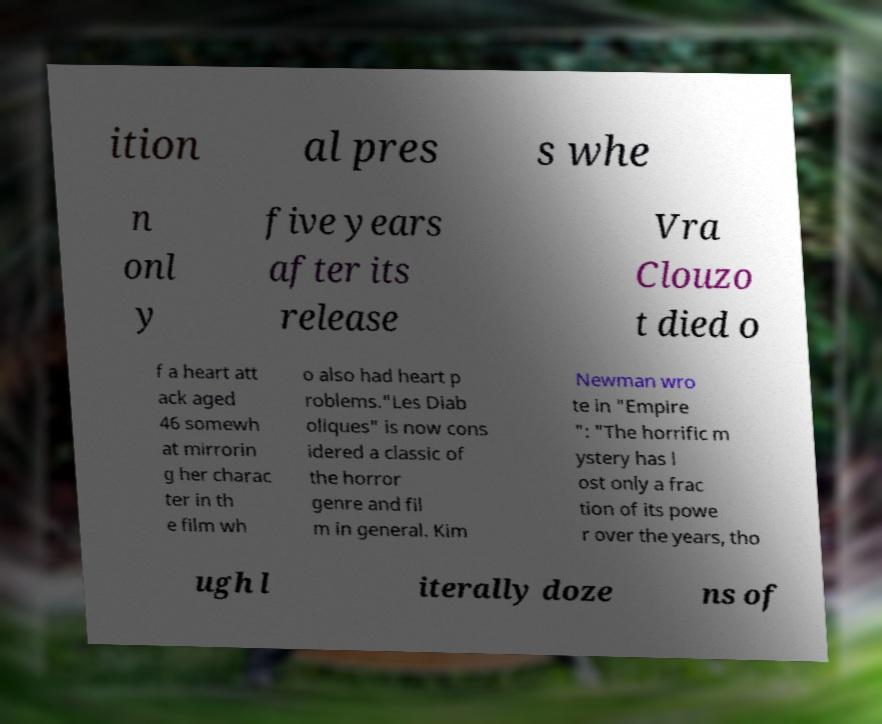Could you extract and type out the text from this image? ition al pres s whe n onl y five years after its release Vra Clouzo t died o f a heart att ack aged 46 somewh at mirrorin g her charac ter in th e film wh o also had heart p roblems."Les Diab oliques" is now cons idered a classic of the horror genre and fil m in general. Kim Newman wro te in "Empire ": "The horrific m ystery has l ost only a frac tion of its powe r over the years, tho ugh l iterally doze ns of 